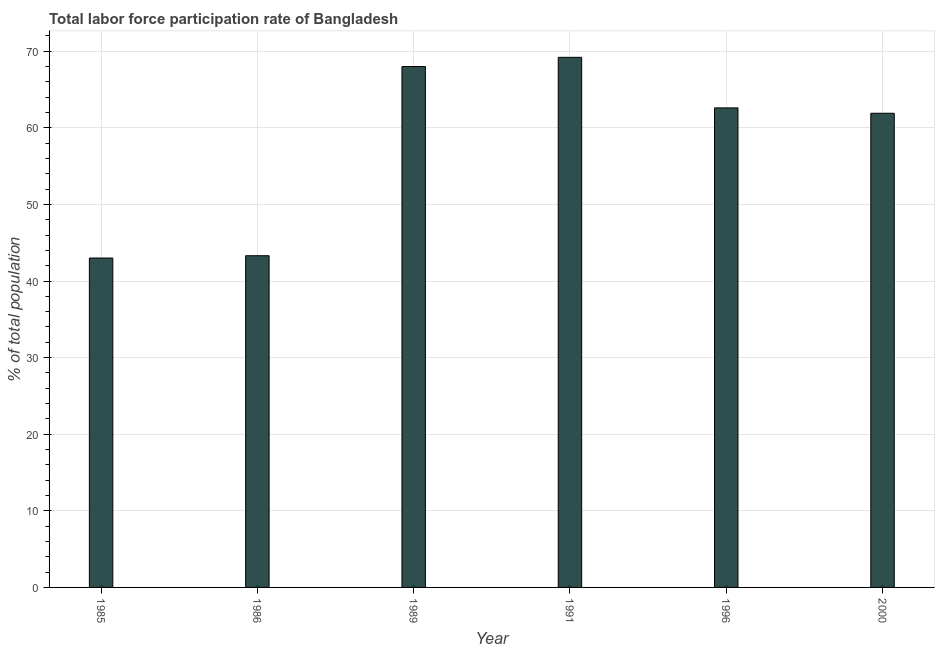Does the graph contain grids?
Offer a very short reply. Yes. What is the title of the graph?
Keep it short and to the point. Total labor force participation rate of Bangladesh. What is the label or title of the Y-axis?
Provide a short and direct response. % of total population. What is the total labor force participation rate in 1996?
Make the answer very short. 62.6. Across all years, what is the maximum total labor force participation rate?
Keep it short and to the point. 69.2. Across all years, what is the minimum total labor force participation rate?
Offer a very short reply. 43. What is the sum of the total labor force participation rate?
Offer a terse response. 348. What is the difference between the total labor force participation rate in 1986 and 1996?
Ensure brevity in your answer.  -19.3. What is the average total labor force participation rate per year?
Your answer should be compact. 58. What is the median total labor force participation rate?
Keep it short and to the point. 62.25. In how many years, is the total labor force participation rate greater than 8 %?
Offer a terse response. 6. What is the ratio of the total labor force participation rate in 1989 to that in 2000?
Make the answer very short. 1.1. What is the difference between the highest and the second highest total labor force participation rate?
Keep it short and to the point. 1.2. What is the difference between the highest and the lowest total labor force participation rate?
Give a very brief answer. 26.2. In how many years, is the total labor force participation rate greater than the average total labor force participation rate taken over all years?
Ensure brevity in your answer.  4. How many bars are there?
Provide a succinct answer. 6. Are all the bars in the graph horizontal?
Offer a very short reply. No. How many years are there in the graph?
Keep it short and to the point. 6. What is the % of total population in 1986?
Provide a short and direct response. 43.3. What is the % of total population in 1991?
Offer a very short reply. 69.2. What is the % of total population in 1996?
Your response must be concise. 62.6. What is the % of total population in 2000?
Offer a terse response. 61.9. What is the difference between the % of total population in 1985 and 1986?
Keep it short and to the point. -0.3. What is the difference between the % of total population in 1985 and 1989?
Offer a very short reply. -25. What is the difference between the % of total population in 1985 and 1991?
Give a very brief answer. -26.2. What is the difference between the % of total population in 1985 and 1996?
Your response must be concise. -19.6. What is the difference between the % of total population in 1985 and 2000?
Make the answer very short. -18.9. What is the difference between the % of total population in 1986 and 1989?
Ensure brevity in your answer.  -24.7. What is the difference between the % of total population in 1986 and 1991?
Provide a short and direct response. -25.9. What is the difference between the % of total population in 1986 and 1996?
Provide a short and direct response. -19.3. What is the difference between the % of total population in 1986 and 2000?
Provide a succinct answer. -18.6. What is the difference between the % of total population in 1989 and 1996?
Provide a short and direct response. 5.4. What is the difference between the % of total population in 1989 and 2000?
Your response must be concise. 6.1. What is the difference between the % of total population in 1996 and 2000?
Give a very brief answer. 0.7. What is the ratio of the % of total population in 1985 to that in 1986?
Your response must be concise. 0.99. What is the ratio of the % of total population in 1985 to that in 1989?
Make the answer very short. 0.63. What is the ratio of the % of total population in 1985 to that in 1991?
Your answer should be very brief. 0.62. What is the ratio of the % of total population in 1985 to that in 1996?
Offer a terse response. 0.69. What is the ratio of the % of total population in 1985 to that in 2000?
Give a very brief answer. 0.69. What is the ratio of the % of total population in 1986 to that in 1989?
Your response must be concise. 0.64. What is the ratio of the % of total population in 1986 to that in 1991?
Keep it short and to the point. 0.63. What is the ratio of the % of total population in 1986 to that in 1996?
Ensure brevity in your answer.  0.69. What is the ratio of the % of total population in 1989 to that in 1991?
Offer a terse response. 0.98. What is the ratio of the % of total population in 1989 to that in 1996?
Give a very brief answer. 1.09. What is the ratio of the % of total population in 1989 to that in 2000?
Provide a short and direct response. 1.1. What is the ratio of the % of total population in 1991 to that in 1996?
Your response must be concise. 1.1. What is the ratio of the % of total population in 1991 to that in 2000?
Offer a very short reply. 1.12. 